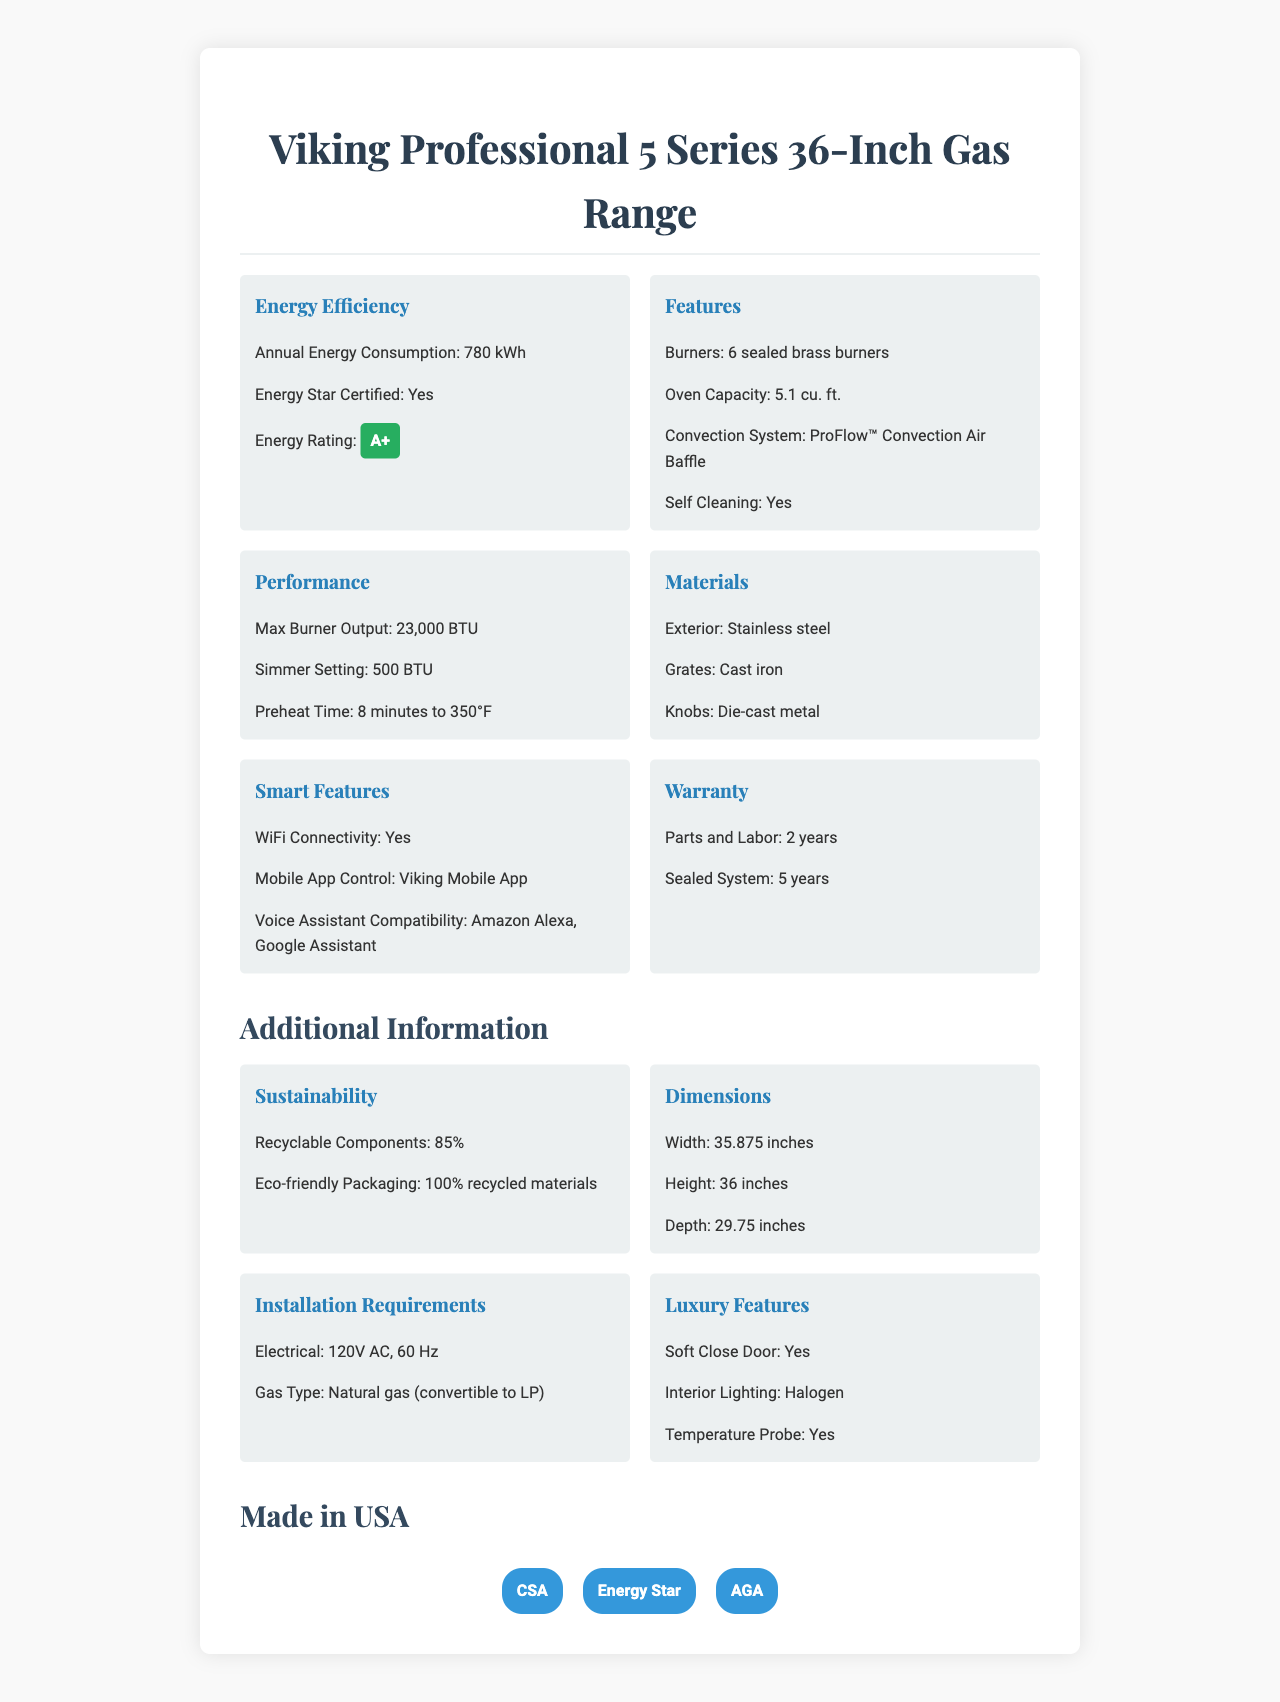how much is the annual energy consumption of the appliance? The annual energy consumption is directly listed under the "Energy Efficiency" section of the document as "780 kWh".
Answer: 780 kWh is the appliance energy star certified? The document states under the "Energy Efficiency" section that the appliance is Energy Star Certified.
Answer: Yes what is the maximum burner output of the gas range? In the "Performance" section, it’s mentioned that the maximum burner output is 23,000 BTU.
Answer: 23,000 BTU how many burners does the appliance have? The number of burners is listed under the "Features" section as 6 sealed brass burners.
Answer: 6 sealed brass burners what is the capacity of the oven? The oven capacity is mentioned under the "Features" section as 5.1 cu. ft.
Answer: 5.1 cu. ft. what is the energy rating of the appliance? A. A++ B. A+ C. B D. C The energy rating is specified under the "Energy Efficiency" section as A+.
Answer: B which voice assistant is compatible with the appliance? A. Alexa B. Google Assistant C. Siri D. Both A and B The "Smart Features" section indicates that the appliance is compatible with both Amazon Alexa and Google Assistant.
Answer: D is the door of the oven designed to close softly? The "Luxury Features" section mentions that the oven has a soft close door.
Answer: Yes summarize the main features and characteristics of the Viking Professional 5 Series 36-Inch Gas Range. This summary encapsulates the key specifications, smart features, performance metrics, and eco-friendly attributes of the Viking Professional 5 Series 36-Inch Gas Range.
Answer: The Viking Professional 5 Series 36-Inch Gas Range is a high-end kitchen appliance with 6 sealed brass burners, a 5.1 cu. ft. oven capacity, and advanced features such as WiFi connectivity and mobile app control. It boasts an annual energy consumption of 780 kWh, an energy rating of A+, and is Energy Star Certified. It is equipped with a ProFlow™ Convection Air Baffle system, self-cleaning capabilities, voice assistant compatibility, and various performance metrics like a max burner output of 23,000 BTU and a simmer setting at 500 BTU. The oven features soft close doors, halogen lighting, and a temperature probe. The appliance is made in the USA and comes with eco-friendly characteristics and a significant warranty period. how long is the warranty for parts and labor? The "Warranty" section specifies that the warranty for parts and labor is 2 years.
Answer: 2 years what is the preheat time to 350°F for the oven? The "Performance" section highlights that the preheat time to 350°F for the oven is 8 minutes.
Answer: 8 minutes where is the Viking Professional 5 Series 36-Inch Gas Range manufactured? It is stated under the "Made in" section that the appliance is made in the USA.
Answer: USA what certifications does the appliance have? The "Certifications" section lists the certifications as CSA, Energy Star, and AGA.
Answer: CSA, Energy Star, AGA what is the average household's gas usage? The document contains specific information about the appliance but does not provide general data on household gas usage.
Answer: Not enough information 